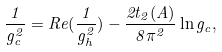Convert formula to latex. <formula><loc_0><loc_0><loc_500><loc_500>\frac { 1 } { g _ { c } ^ { 2 } } = R e ( \frac { 1 } { g _ { h } ^ { 2 } } ) - \frac { 2 t _ { 2 } ( A ) } { 8 \pi ^ { 2 } } \ln g _ { c } ,</formula> 